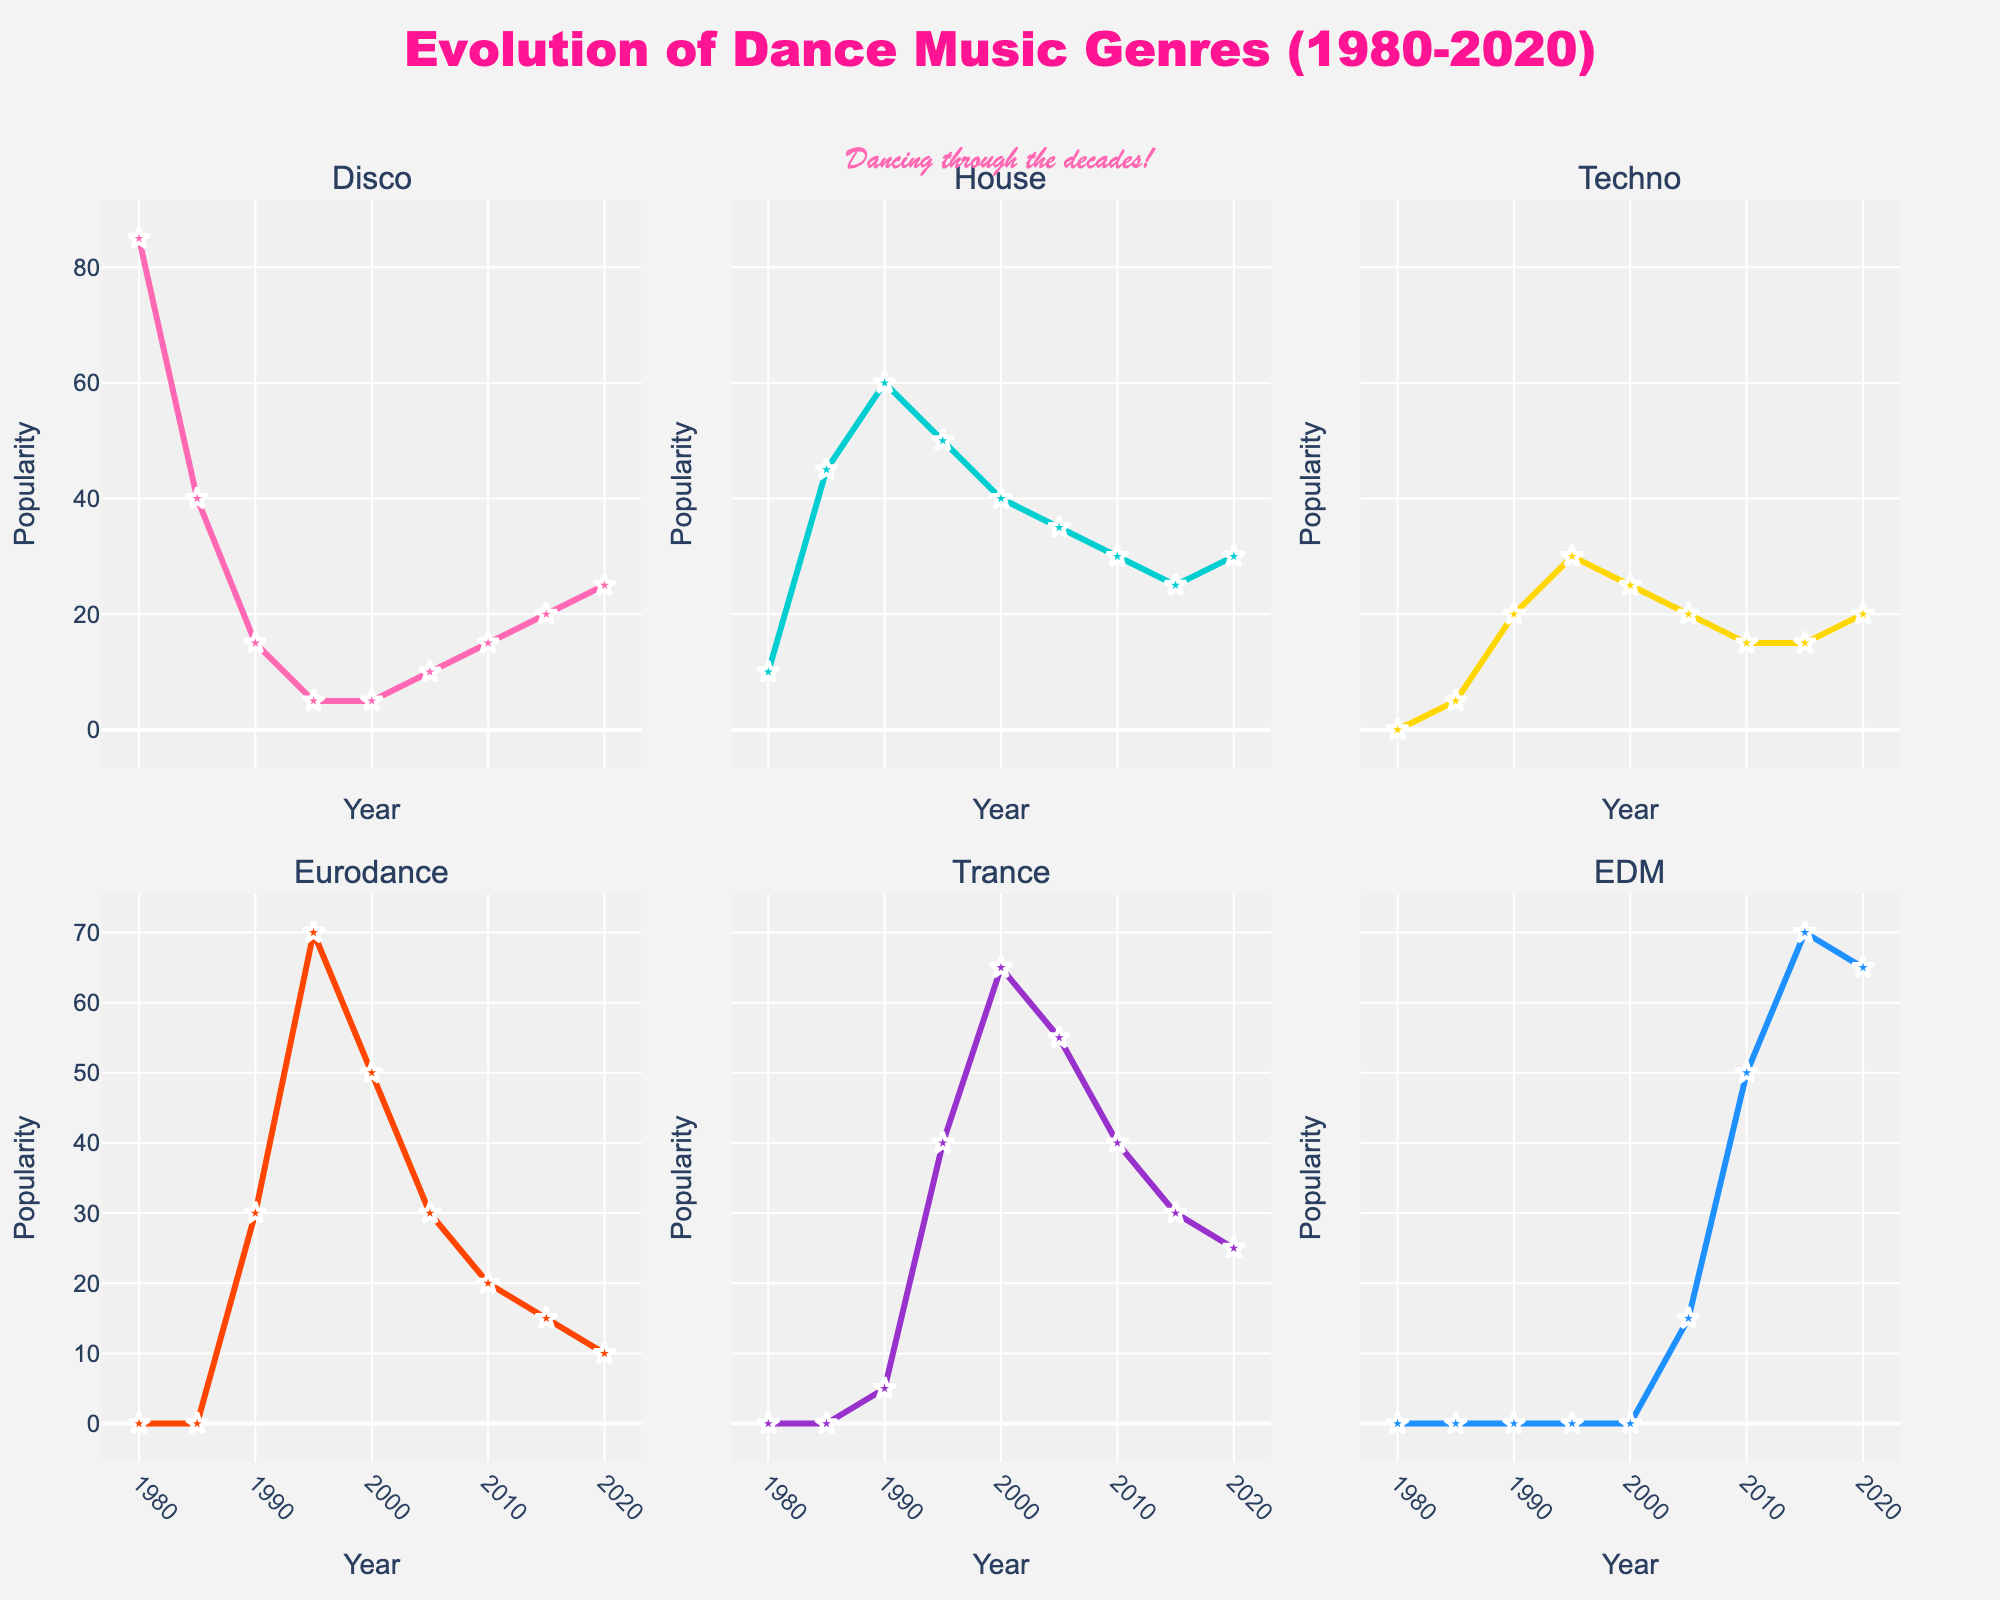what is the title of the figure? The figure title is displayed at the top center of the plot and reads "Evolution of Dance Music Genres (1980-2020)."
Answer: Evolution of Dance Music Genres (1980-2020) What genre shows a decrease in popularity from 1980 to 1985? The Disco genre shows a decline in popularity, decreasing from 85 in 1980 to 40 in 1985, as seen in its subplot.
Answer: Disco Compare the peak popularity years between Eurodance and EDM. Eurodance reaches its peak popularity around 1995 with a value of 70, while EDM peaks in 2015 with a value of 70. Examining the subplots, these peaks can be observed.
Answer: 1995 for Eurodance, 2015 for EDM How does the popularity of House music change from 1990 to 2020? From 1990 to 2020, House music's popularity initially increases from 60 in 1990 to 50 in 1995, then decreases gradually to 30 by 2020. Observing the subplot for House, these trends can be noted.
Answer: Increases then decreases Which genre shows the highest popularity in 2000? Trance shows the highest popularity in 2000, with its value reaching 65 as noted in its subplot.
Answer: Trance From 1985 to 1990, which genre experienced the largest increase in popularity? House music experienced the largest increase, going from 45 in 1985 to 60 in 1990, as seen in its subplot comparing the two years.
Answer: House What is the pattern of change for Techno music from 1995 to 2010? Techno music shows a consistent decline from 1995 (30) to 2010 (15), before stabilizing at this level. Observing the Techno subplot, these values indicate the drop during this period.
Answer: Decline Identify the years when Disco has the same popularity. Disco has a popularity score of 5 in both 1995 and 2000, as observed in its subplot.
Answer: 1995 and 2000 What is the overall trend for EDM from 2005 to 2020? EDM shows a significant rising trend from 15 in 2005, peaking at 70 in 2015, then slightly dropping to 65 in 2020. The subplot for EDM indicates this upward trend.
Answer: Increasing Compare the popularity of Trance and Techno in 2010 and determine which is more popular. In 2010, Trance has a popularity of 40, while Techno has a popularity of 15, making Trance more popular. This is evident from comparing the subplots for both genres.
Answer: Trance 